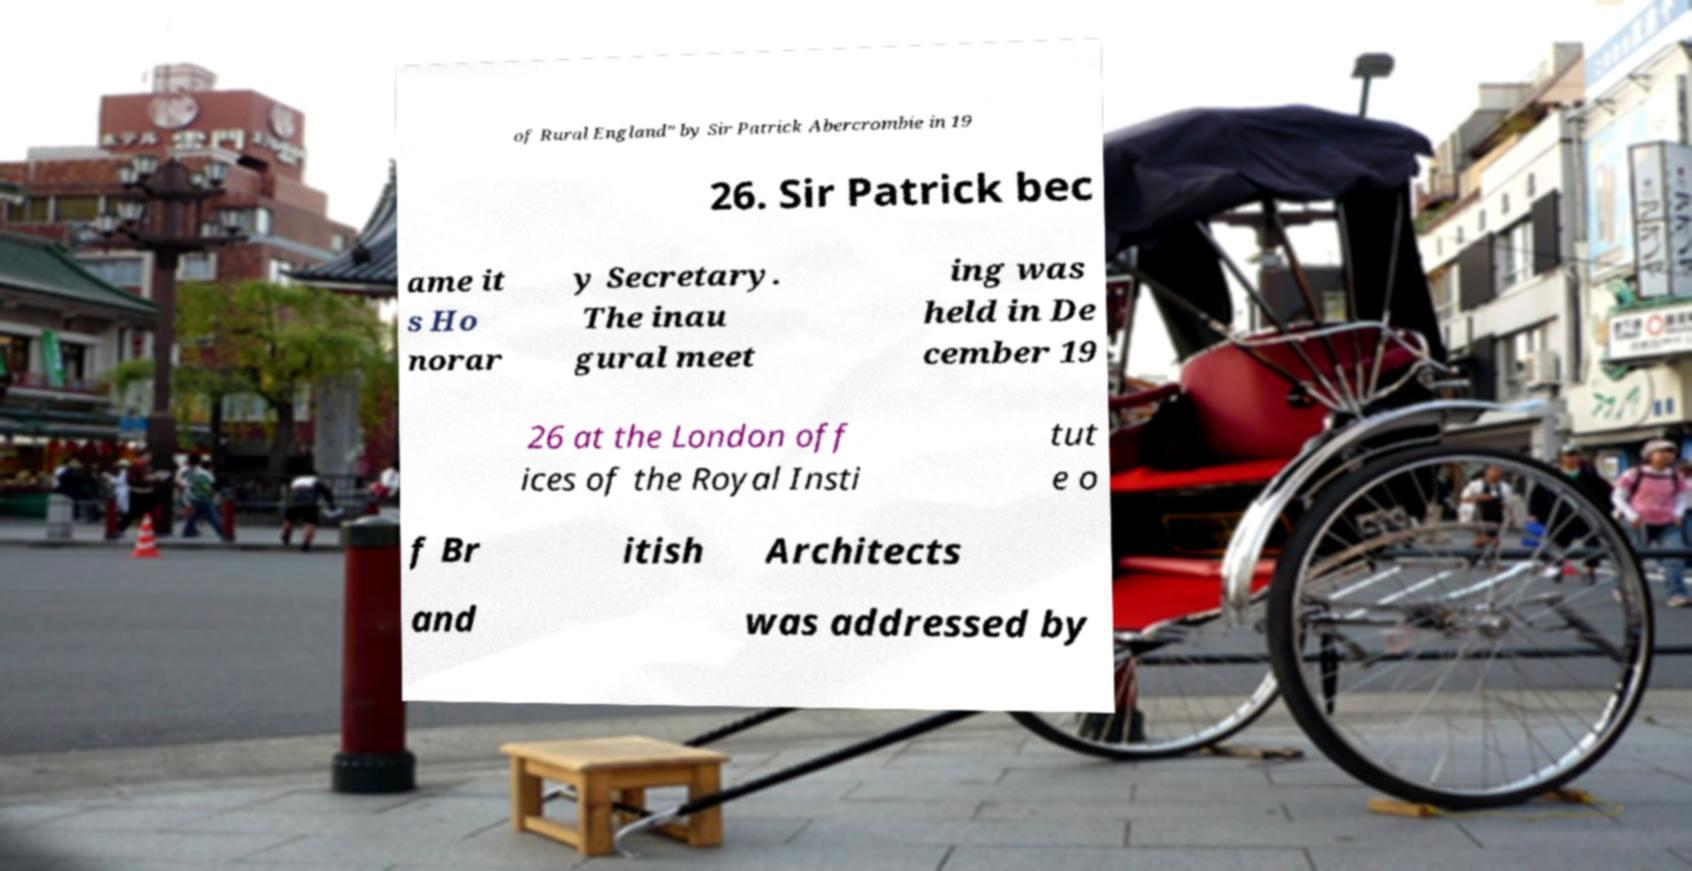What messages or text are displayed in this image? I need them in a readable, typed format. of Rural England” by Sir Patrick Abercrombie in 19 26. Sir Patrick bec ame it s Ho norar y Secretary. The inau gural meet ing was held in De cember 19 26 at the London off ices of the Royal Insti tut e o f Br itish Architects and was addressed by 